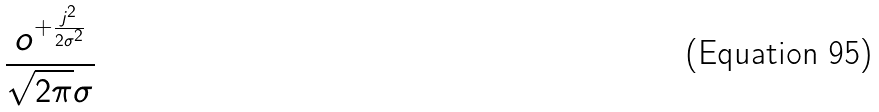Convert formula to latex. <formula><loc_0><loc_0><loc_500><loc_500>\frac { o ^ { + \frac { j ^ { 2 } } { 2 \sigma ^ { 2 } } } } { \sqrt { 2 \pi } \sigma }</formula> 